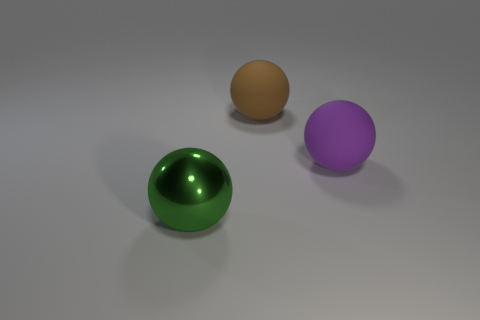There is a brown sphere; is its size the same as the green shiny object that is left of the large purple sphere?
Ensure brevity in your answer.  Yes. Are there any rubber spheres in front of the big sphere in front of the purple object?
Offer a terse response. No. There is a big sphere that is in front of the big brown object and behind the green object; what material is it?
Give a very brief answer. Rubber. What is the color of the large matte object right of the big thing behind the large object that is right of the brown matte sphere?
Ensure brevity in your answer.  Purple. What color is the other rubber sphere that is the same size as the purple rubber sphere?
Provide a short and direct response. Brown. Do the big shiny ball and the matte object that is behind the purple matte object have the same color?
Your answer should be compact. No. There is a big ball behind the thing that is right of the brown object; what is it made of?
Make the answer very short. Rubber. How many big things are both in front of the large brown object and behind the big green ball?
Your answer should be very brief. 1. Is the shape of the object that is to the left of the brown sphere the same as the big matte object to the left of the large purple rubber ball?
Provide a succinct answer. Yes. There is a green shiny thing; are there any purple things in front of it?
Provide a short and direct response. No. 